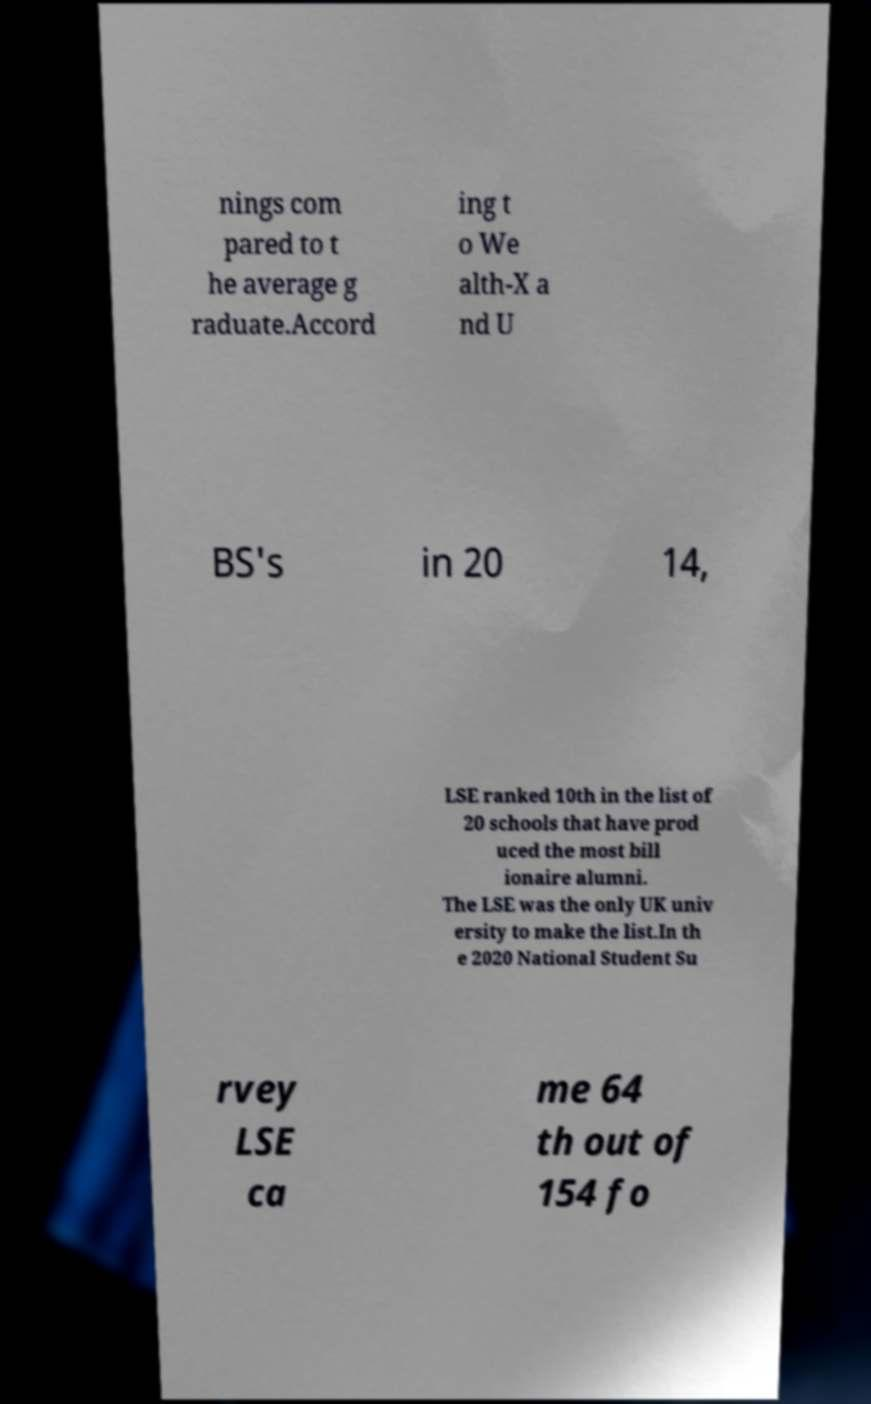Could you assist in decoding the text presented in this image and type it out clearly? nings com pared to t he average g raduate.Accord ing t o We alth-X a nd U BS's in 20 14, LSE ranked 10th in the list of 20 schools that have prod uced the most bill ionaire alumni. The LSE was the only UK univ ersity to make the list.In th e 2020 National Student Su rvey LSE ca me 64 th out of 154 fo 